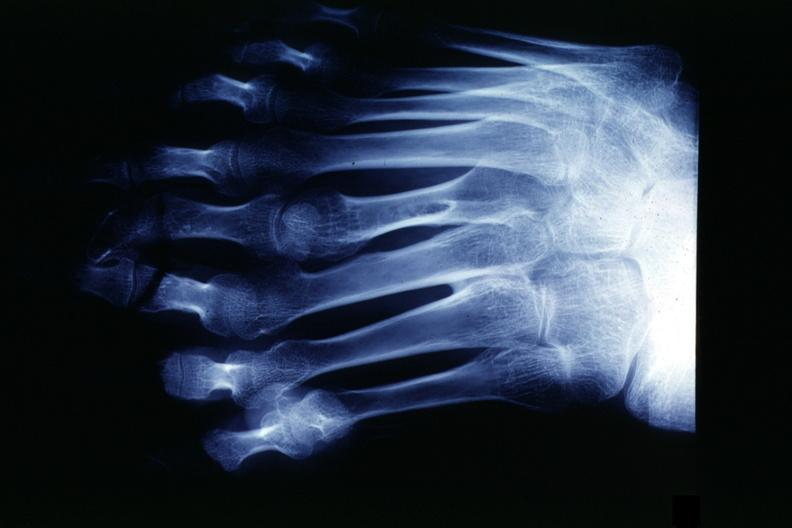s marfans syndrome present?
Answer the question using a single word or phrase. No 